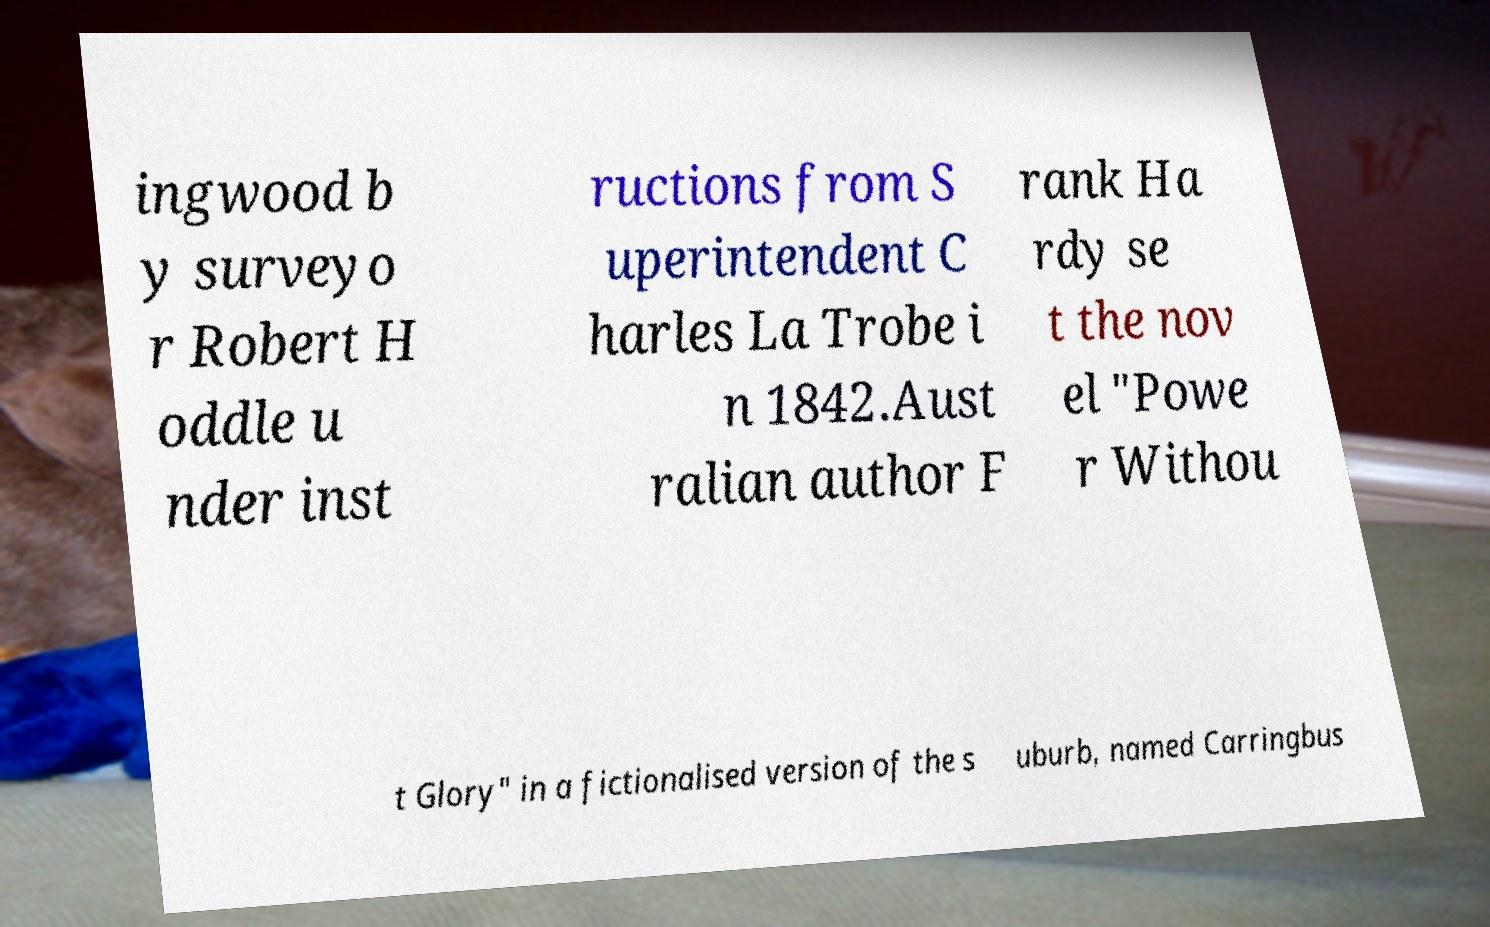What messages or text are displayed in this image? I need them in a readable, typed format. ingwood b y surveyo r Robert H oddle u nder inst ructions from S uperintendent C harles La Trobe i n 1842.Aust ralian author F rank Ha rdy se t the nov el "Powe r Withou t Glory" in a fictionalised version of the s uburb, named Carringbus 